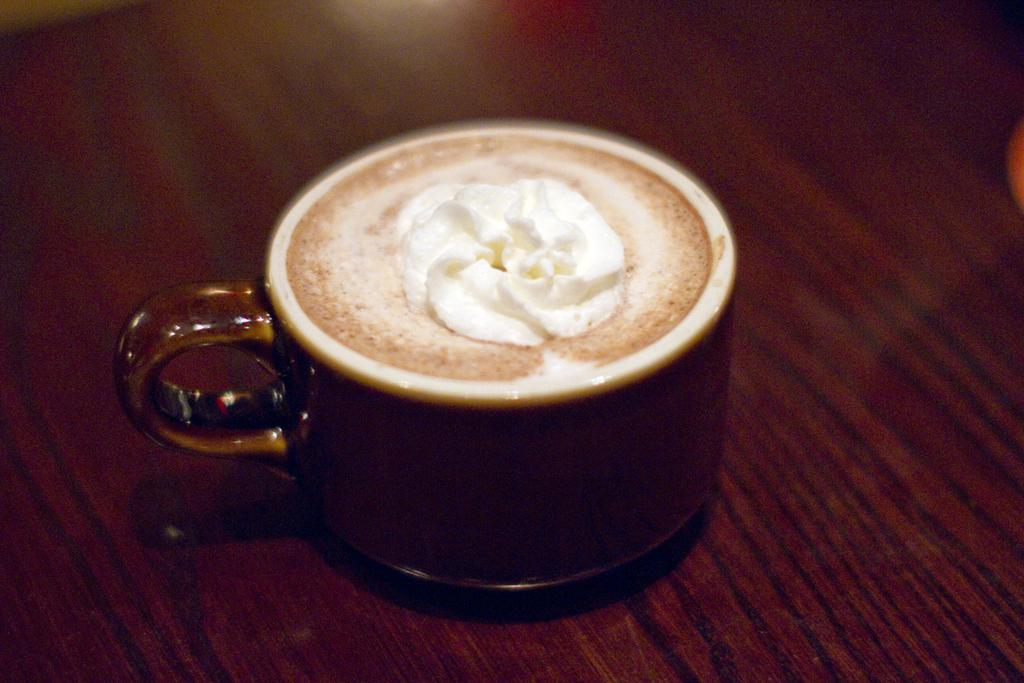What object is on the table in the image? There is a cup on a table in the image. What is inside the cup? There is a drink and cream in the cup. What type of love is being expressed at the party in the image? There is no party or love being expressed in the image; it only shows a cup with a drink and cream on a table. 